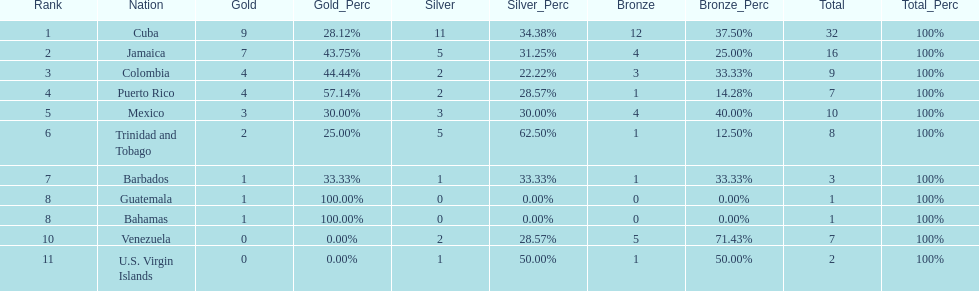Parse the table in full. {'header': ['Rank', 'Nation', 'Gold', 'Gold_Perc', 'Silver', 'Silver_Perc', 'Bronze', 'Bronze_Perc', 'Total', 'Total_Perc'], 'rows': [['1', 'Cuba', '9', '28.12%', '11', '34.38%', '12', '37.50%', '32', '100%'], ['2', 'Jamaica', '7', '43.75%', '5', '31.25%', '4', '25.00%', '16', '100%'], ['3', 'Colombia', '4', '44.44%', '2', '22.22%', '3', '33.33%', '9', '100%'], ['4', 'Puerto Rico', '4', '57.14%', '2', '28.57%', '1', '14.28%', '7', '100%'], ['5', 'Mexico', '3', '30.00%', '3', '30.00%', '4', '40.00%', '10', '100%'], ['6', 'Trinidad and Tobago', '2', '25.00%', '5', '62.50%', '1', '12.50%', '8', '100%'], ['7', 'Barbados', '1', '33.33%', '1', '33.33%', '1', '33.33%', '3', '100%'], ['8', 'Guatemala', '1', '100.00%', '0', '0.00%', '0', '0.00%', '1', '100%'], ['8', 'Bahamas', '1', '100.00%', '0', '0.00%', '0', '0.00%', '1', '100%'], ['10', 'Venezuela', '0', '0.00%', '2', '28.57%', '5', '71.43%', '7', '100%'], ['11', 'U.S. Virgin Islands', '0', '0.00%', '1', '50.00%', '1', '50.00%', '2', '100%']]} What is the difference in medals between cuba and mexico? 22. 